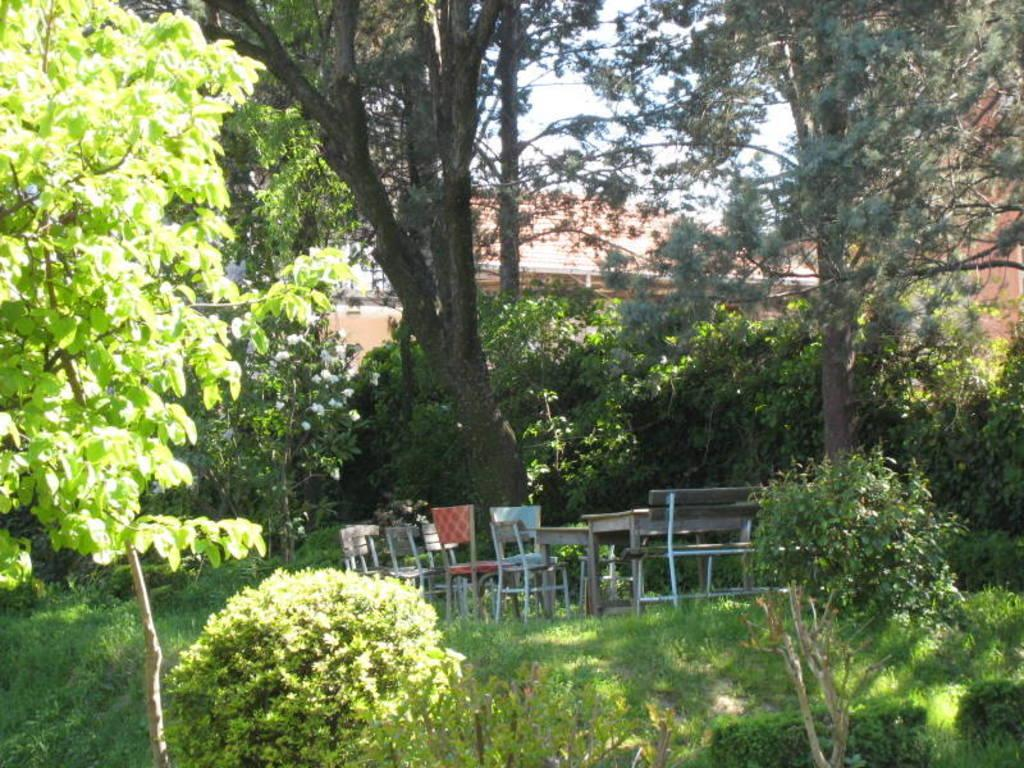What type of vegetation can be seen in the image? There are plants and trees in the image. What type of furniture is present in the image? There is a table and chairs in the image. What can be seen in the background of the image? There is a house in the background of the image. How many pieces of apparel are hanging on the trees in the image? There is no apparel hanging on the trees in the image. What is the amount of ants crawling on the table in the image? There are no ants present in the image. 